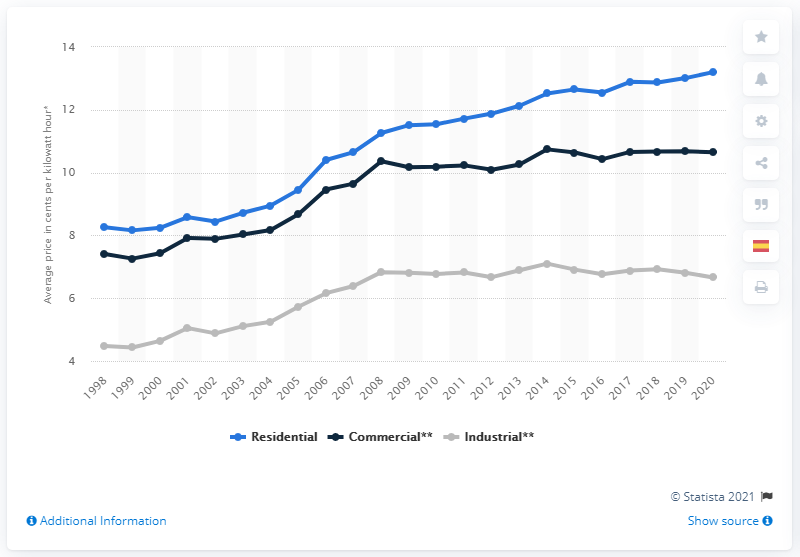Draw attention to some important aspects in this diagram. The average retail price of electricity for residential customers in the United States was 13.2 cents per kilowatt-hour in the year 2020. 